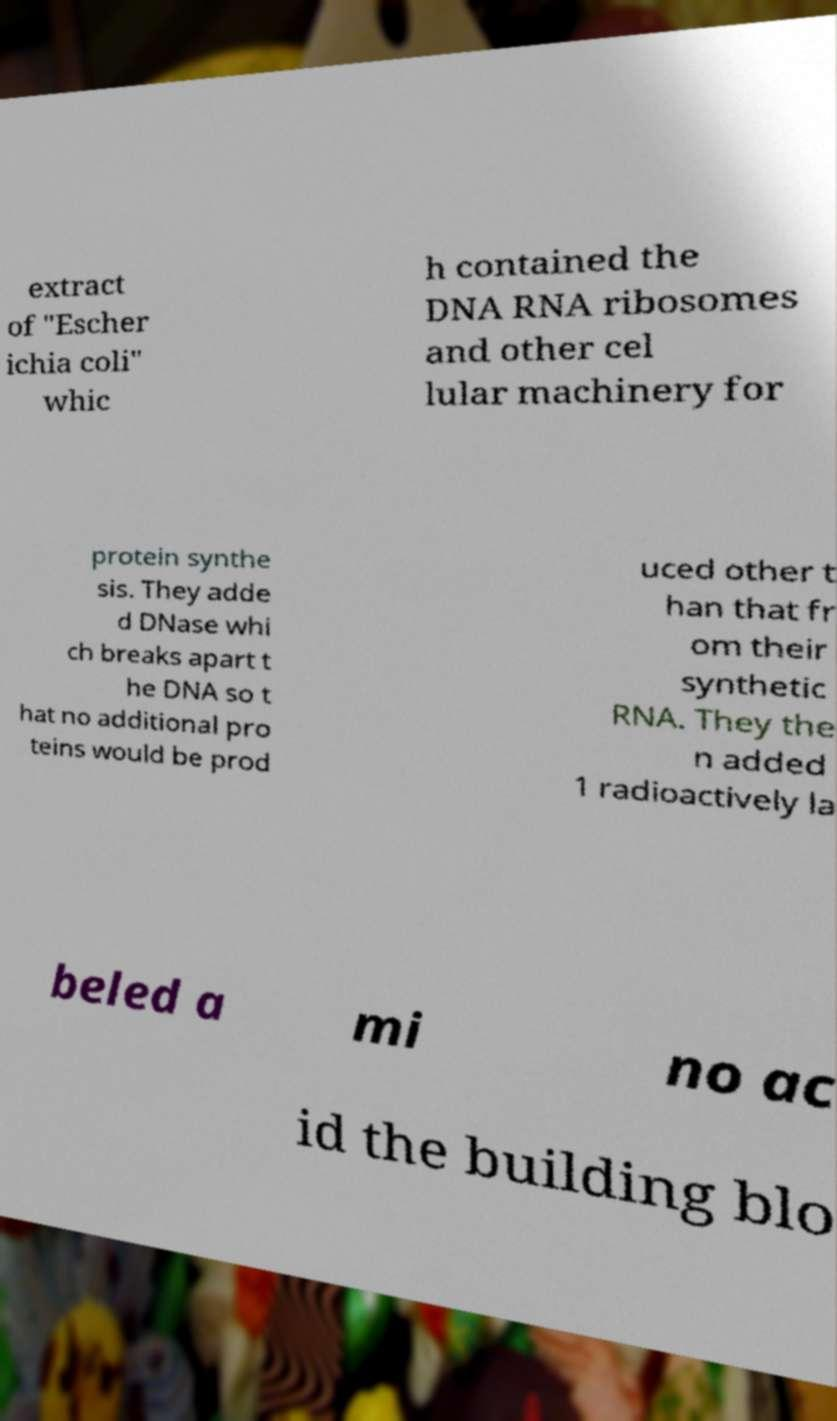Can you read and provide the text displayed in the image?This photo seems to have some interesting text. Can you extract and type it out for me? extract of "Escher ichia coli" whic h contained the DNA RNA ribosomes and other cel lular machinery for protein synthe sis. They adde d DNase whi ch breaks apart t he DNA so t hat no additional pro teins would be prod uced other t han that fr om their synthetic RNA. They the n added 1 radioactively la beled a mi no ac id the building blo 